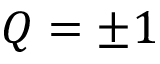<formula> <loc_0><loc_0><loc_500><loc_500>Q = \pm 1</formula> 